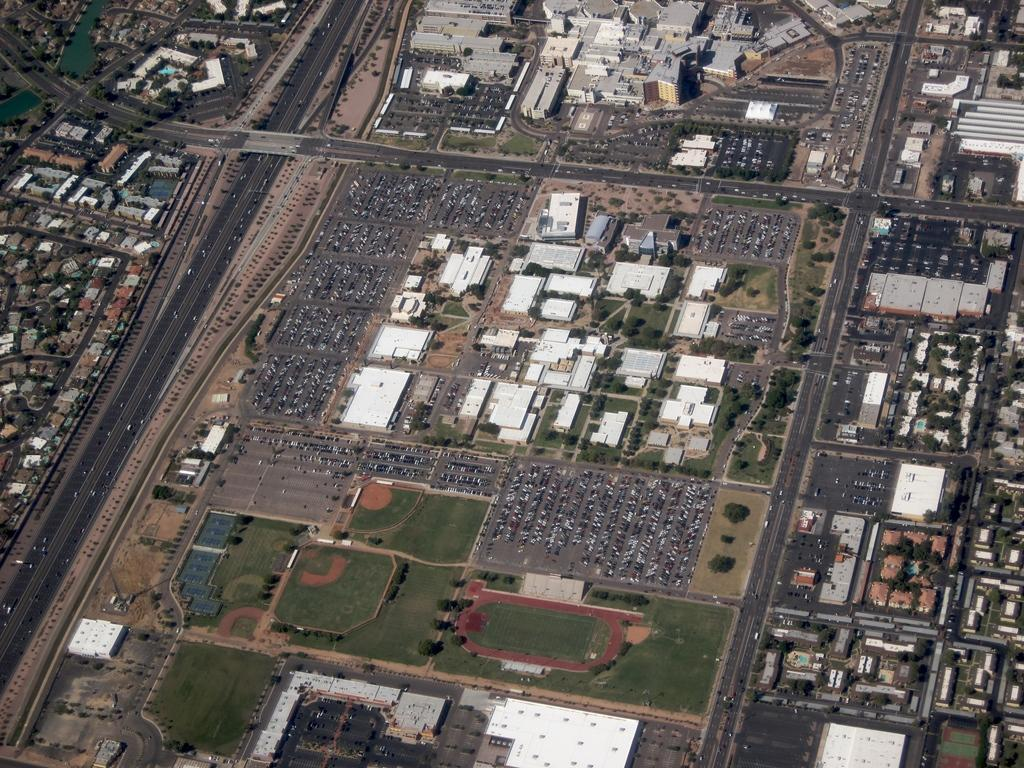What type of structures can be seen in the image? There are buildings in the image. What else can be seen on the ground in the image? There are roads in the image. What type of vegetation is present in the image? There are trees and grass in the image. What else can be found in the image besides buildings, roads, trees, and grass? There are objects in the image. Where is the shelf located in the image? There is no shelf present in the image. Can you tell me how many geese are depicted in the image? There are no geese depicted in the image. 